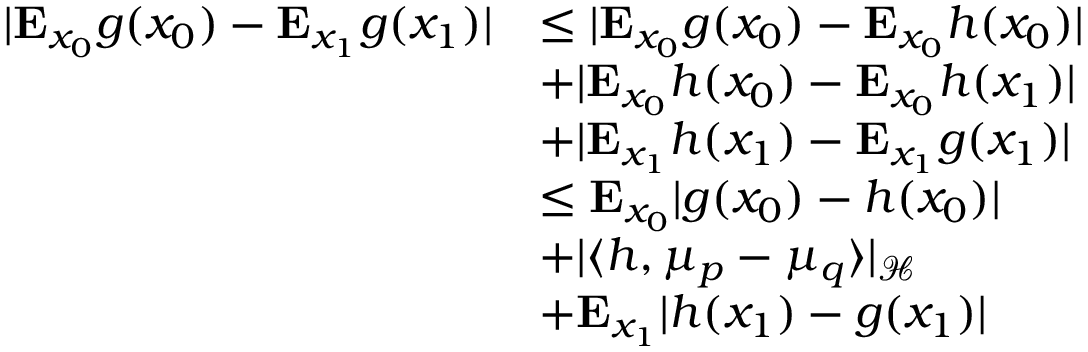<formula> <loc_0><loc_0><loc_500><loc_500>\begin{array} { r l } { | E _ { x _ { 0 } } g ( x _ { 0 } ) - E _ { x _ { 1 } } g ( x _ { 1 } ) | } & { \leq | E _ { x _ { 0 } } g ( x _ { 0 } ) - E _ { x _ { 0 } } h ( x _ { 0 } ) | } \\ & { + | E _ { x _ { 0 } } h ( x _ { 0 } ) - E _ { x _ { 0 } } h ( x _ { 1 } ) | } \\ & { + | E _ { x _ { 1 } } h ( x _ { 1 } ) - E _ { x _ { 1 } } g ( x _ { 1 } ) | } \\ & { \leq E _ { x _ { 0 } } | g ( x _ { 0 } ) - h ( x _ { 0 } ) | } \\ & { + | \langle h , \mu _ { p } - \mu _ { q } \rangle | _ { \mathcal { H } } } \\ & { + E _ { x _ { 1 } } | h ( x _ { 1 } ) - g ( x _ { 1 } ) | } \end{array}</formula> 